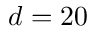<formula> <loc_0><loc_0><loc_500><loc_500>d = 2 0</formula> 